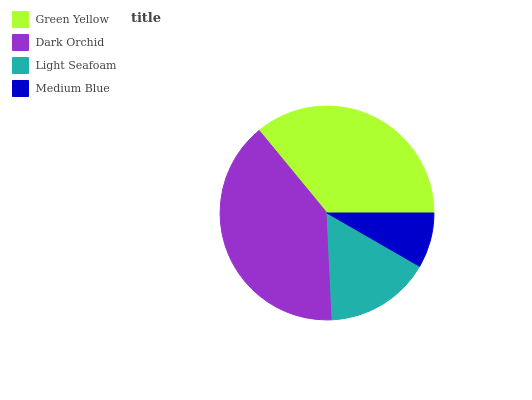Is Medium Blue the minimum?
Answer yes or no. Yes. Is Dark Orchid the maximum?
Answer yes or no. Yes. Is Light Seafoam the minimum?
Answer yes or no. No. Is Light Seafoam the maximum?
Answer yes or no. No. Is Dark Orchid greater than Light Seafoam?
Answer yes or no. Yes. Is Light Seafoam less than Dark Orchid?
Answer yes or no. Yes. Is Light Seafoam greater than Dark Orchid?
Answer yes or no. No. Is Dark Orchid less than Light Seafoam?
Answer yes or no. No. Is Green Yellow the high median?
Answer yes or no. Yes. Is Light Seafoam the low median?
Answer yes or no. Yes. Is Dark Orchid the high median?
Answer yes or no. No. Is Medium Blue the low median?
Answer yes or no. No. 